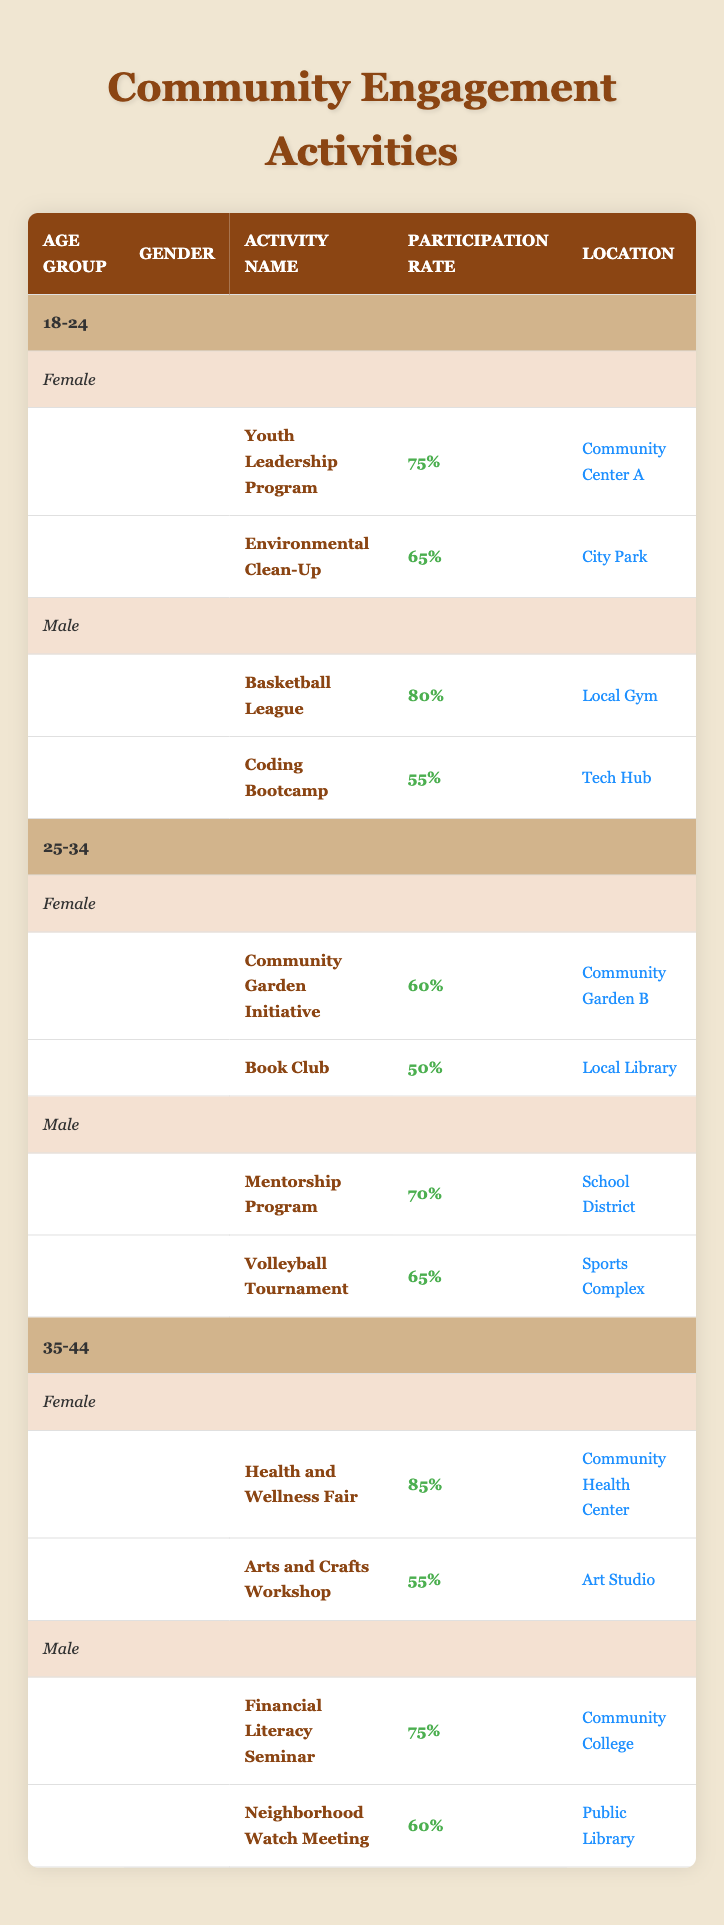What is the activity with the highest participation rate for females aged 35-44? The activity with the highest participation rate for females aged 35-44 is the "Health and Wellness Fair," which has a participation rate of 85%.
Answer: Health and Wellness Fair What is the average participation rate for male participants in the 25-34 age group? The participation rates for males aged 25-34 are 70% for the Mentorship Program and 65% for the Volleyball Tournament. To find the average, add these values (70 + 65 = 135) and then divide by the number of activities (135/2 = 67.5).
Answer: 67.5 Is the participation rate for the "Environmental Clean-Up" higher than the "Book Club"? The participation rate for the "Environmental Clean-Up" is 65%, while the "Book Club" has a participation rate of 50%. Since 65% is greater than 50%, the answer is yes.
Answer: Yes What are the locations of participation activities for females aged 18-24? For females aged 18-24, the locations of activities are "Community Center A" for the "Youth Leadership Program" and "City Park" for the "Environmental Clean-Up."
Answer: Community Center A, City Park What is the difference in participation rates between the highest and lowest activities for males aged 18-24? The highest participation rate for males aged 18-24 is 80% for the Basketball League, and the lowest is 55% for the Coding Bootcamp. To find the difference, subtract the lower rate from the higher rate (80 - 55 = 25).
Answer: 25 What activities are available for 25-34-year-old females, and how do their participation rates compare to those of males in the same age group? The activities for females aged 25-34 are the "Community Garden Initiative" (60%) and the "Book Club" (50%). For males, the "Mentorship Program" (70%) and the "Volleyball Tournament" (65%) have higher participation rates. Females have an average of 55% (60 + 50 = 110, 110/2 = 55), which is lower than the males' average of 67.5%.
Answer: Females: 60%, 50%; Males: 70%, 65% (Males have higher rates) Are there any activities for males in the 35-44 age group that have a participation rate below 65%? Yes, the "Neighborhood Watch Meeting" for males in the 35-44 age group has a participation rate of 60%, which is below 65%.
Answer: Yes Which age group has the highest participation rate for any activity? The age group 35-44 has the highest participation rate for the "Health and Wellness Fair" at 85%. No other age group exceeds this rate.
Answer: 35-44 